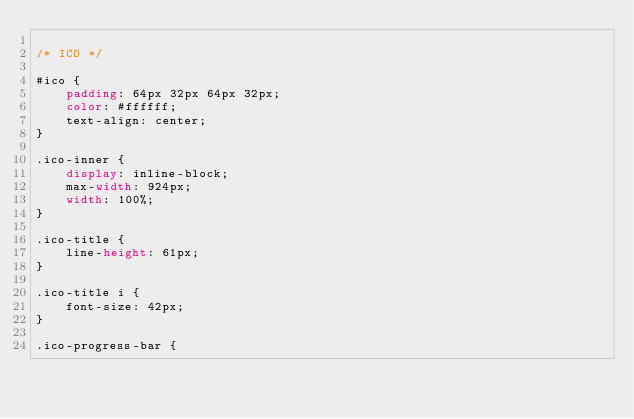Convert code to text. <code><loc_0><loc_0><loc_500><loc_500><_CSS_>
/* ICO */

#ico {
    padding: 64px 32px 64px 32px;
    color: #ffffff;
    text-align: center;
}

.ico-inner {
    display: inline-block;
    max-width: 924px;
    width: 100%;
}

.ico-title {
    line-height: 61px;
}

.ico-title i {
    font-size: 42px;
}

.ico-progress-bar {</code> 